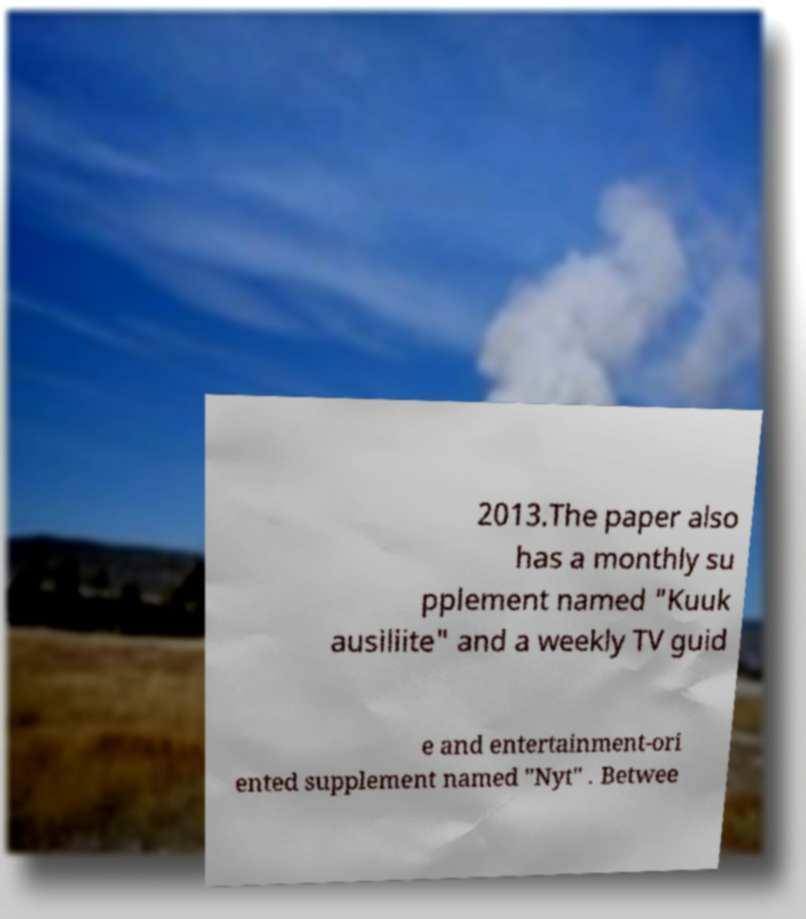I need the written content from this picture converted into text. Can you do that? 2013.The paper also has a monthly su pplement named "Kuuk ausiliite" and a weekly TV guid e and entertainment-ori ented supplement named "Nyt" . Betwee 